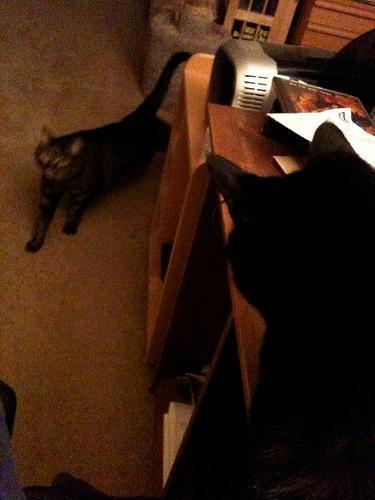How many cats are shown?
Give a very brief answer. 2. How many cats are seen?
Give a very brief answer. 2. How many cats?
Give a very brief answer. 2. 